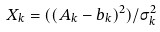Convert formula to latex. <formula><loc_0><loc_0><loc_500><loc_500>X _ { k } = ( ( A _ { k } - b _ { k } ) ^ { 2 } ) / \sigma ^ { 2 } _ { k }</formula> 